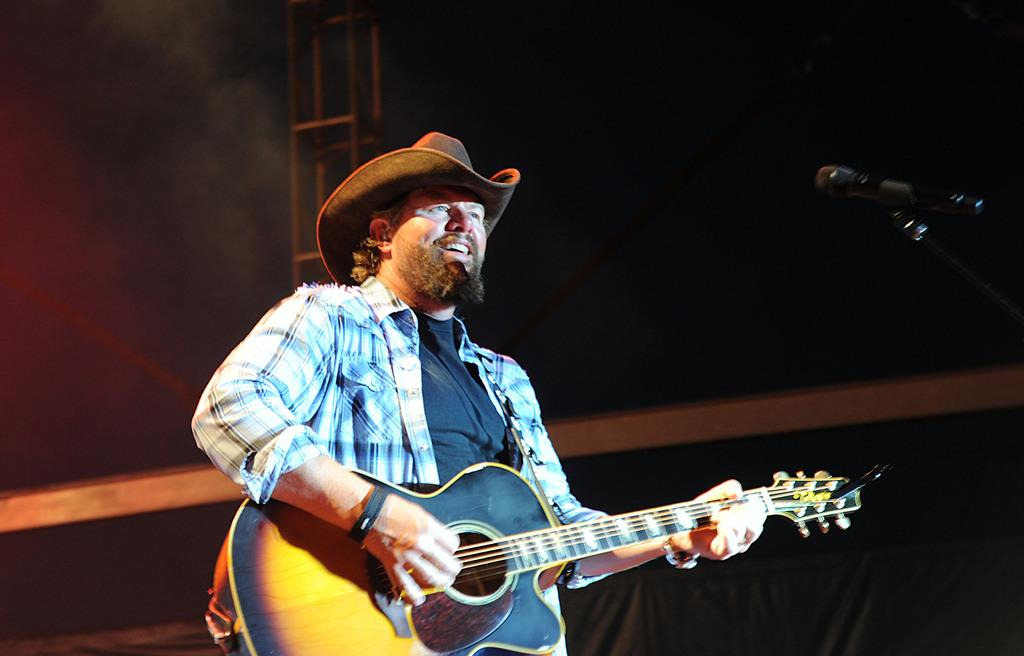What is the person in the image doing? The person is playing a guitar. What type of clothing is the person wearing? The person is wearing a shirt and a hat. Can you describe any equipment related to music in the image? There is a microphone with a holder in the image. What type of plate is being used to play the guitar in the image? There is no plate being used to play the guitar in the image; the person is playing a traditional guitar. How many songs can be heard being sung into the appliance in the image? There is no appliance present in the image, and no singing is taking place. 